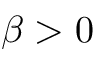Convert formula to latex. <formula><loc_0><loc_0><loc_500><loc_500>\beta > 0</formula> 